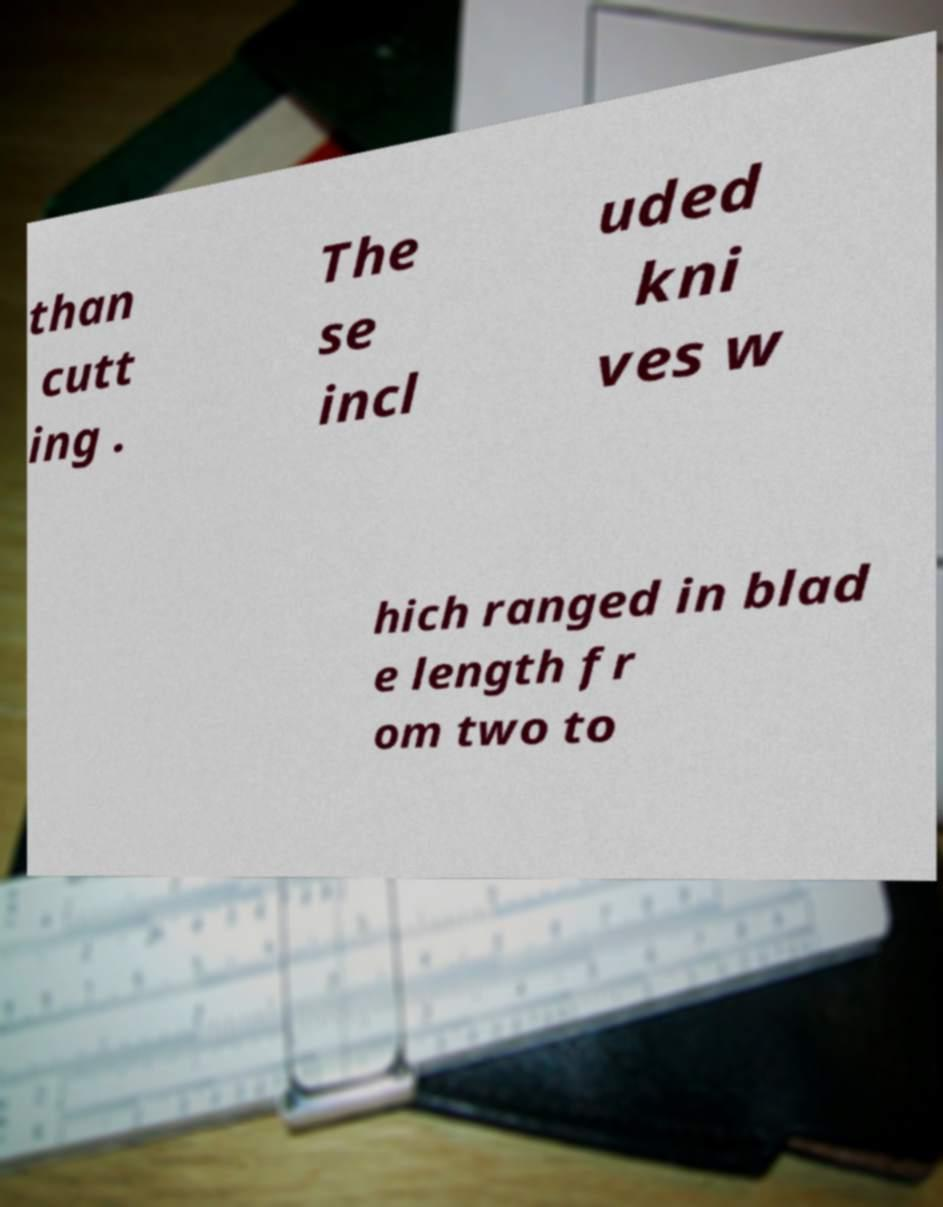What messages or text are displayed in this image? I need them in a readable, typed format. than cutt ing . The se incl uded kni ves w hich ranged in blad e length fr om two to 